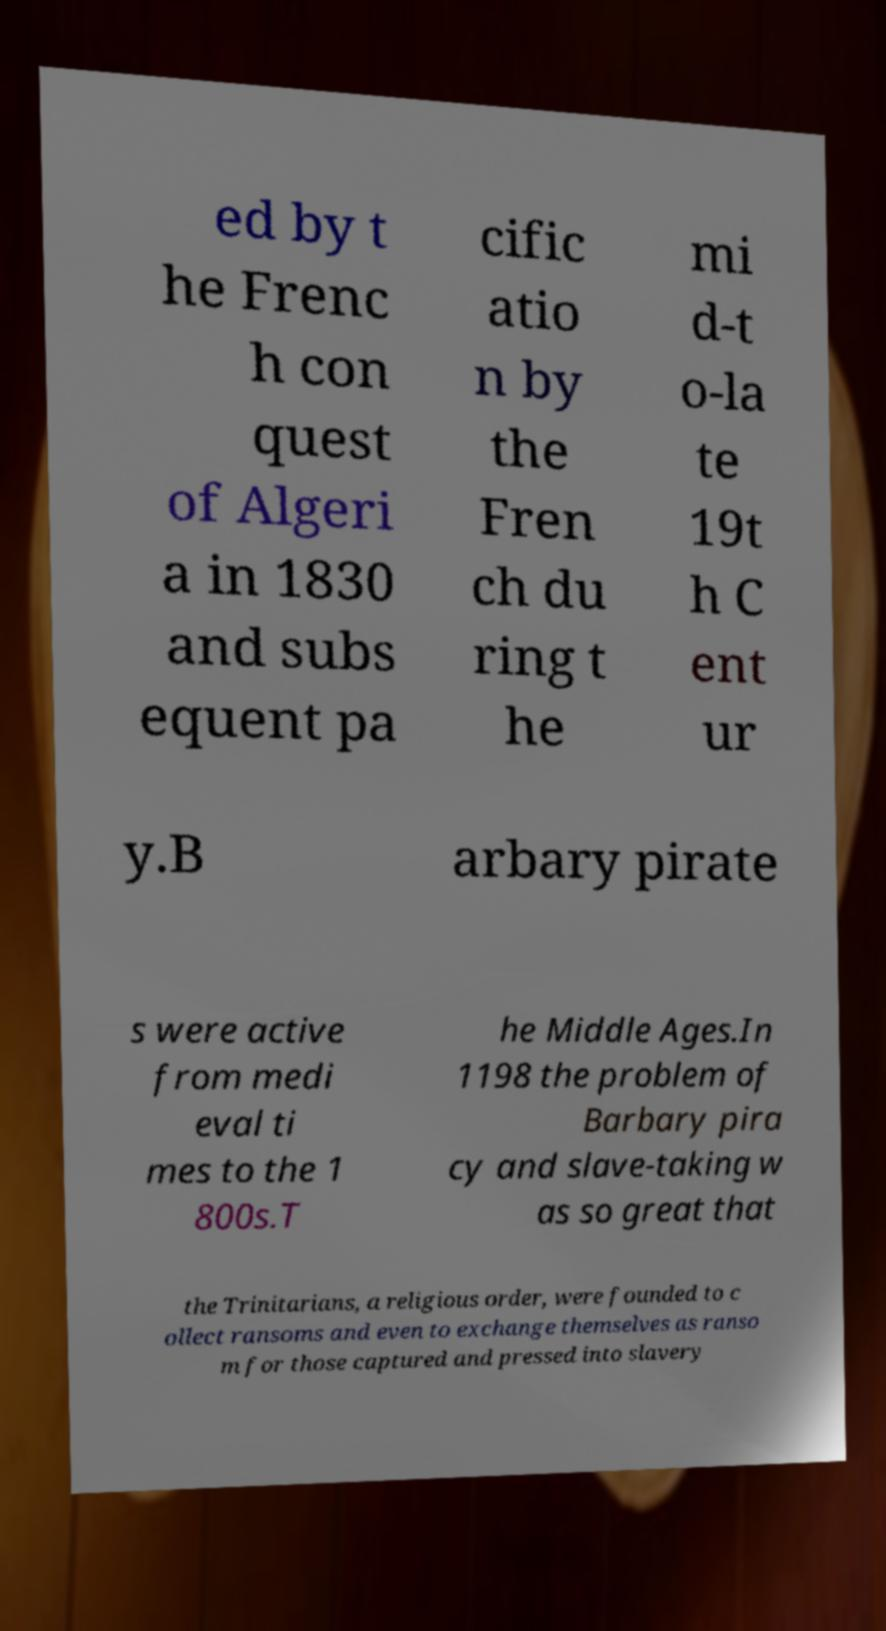Can you accurately transcribe the text from the provided image for me? ed by t he Frenc h con quest of Algeri a in 1830 and subs equent pa cific atio n by the Fren ch du ring t he mi d-t o-la te 19t h C ent ur y.B arbary pirate s were active from medi eval ti mes to the 1 800s.T he Middle Ages.In 1198 the problem of Barbary pira cy and slave-taking w as so great that the Trinitarians, a religious order, were founded to c ollect ransoms and even to exchange themselves as ranso m for those captured and pressed into slavery 